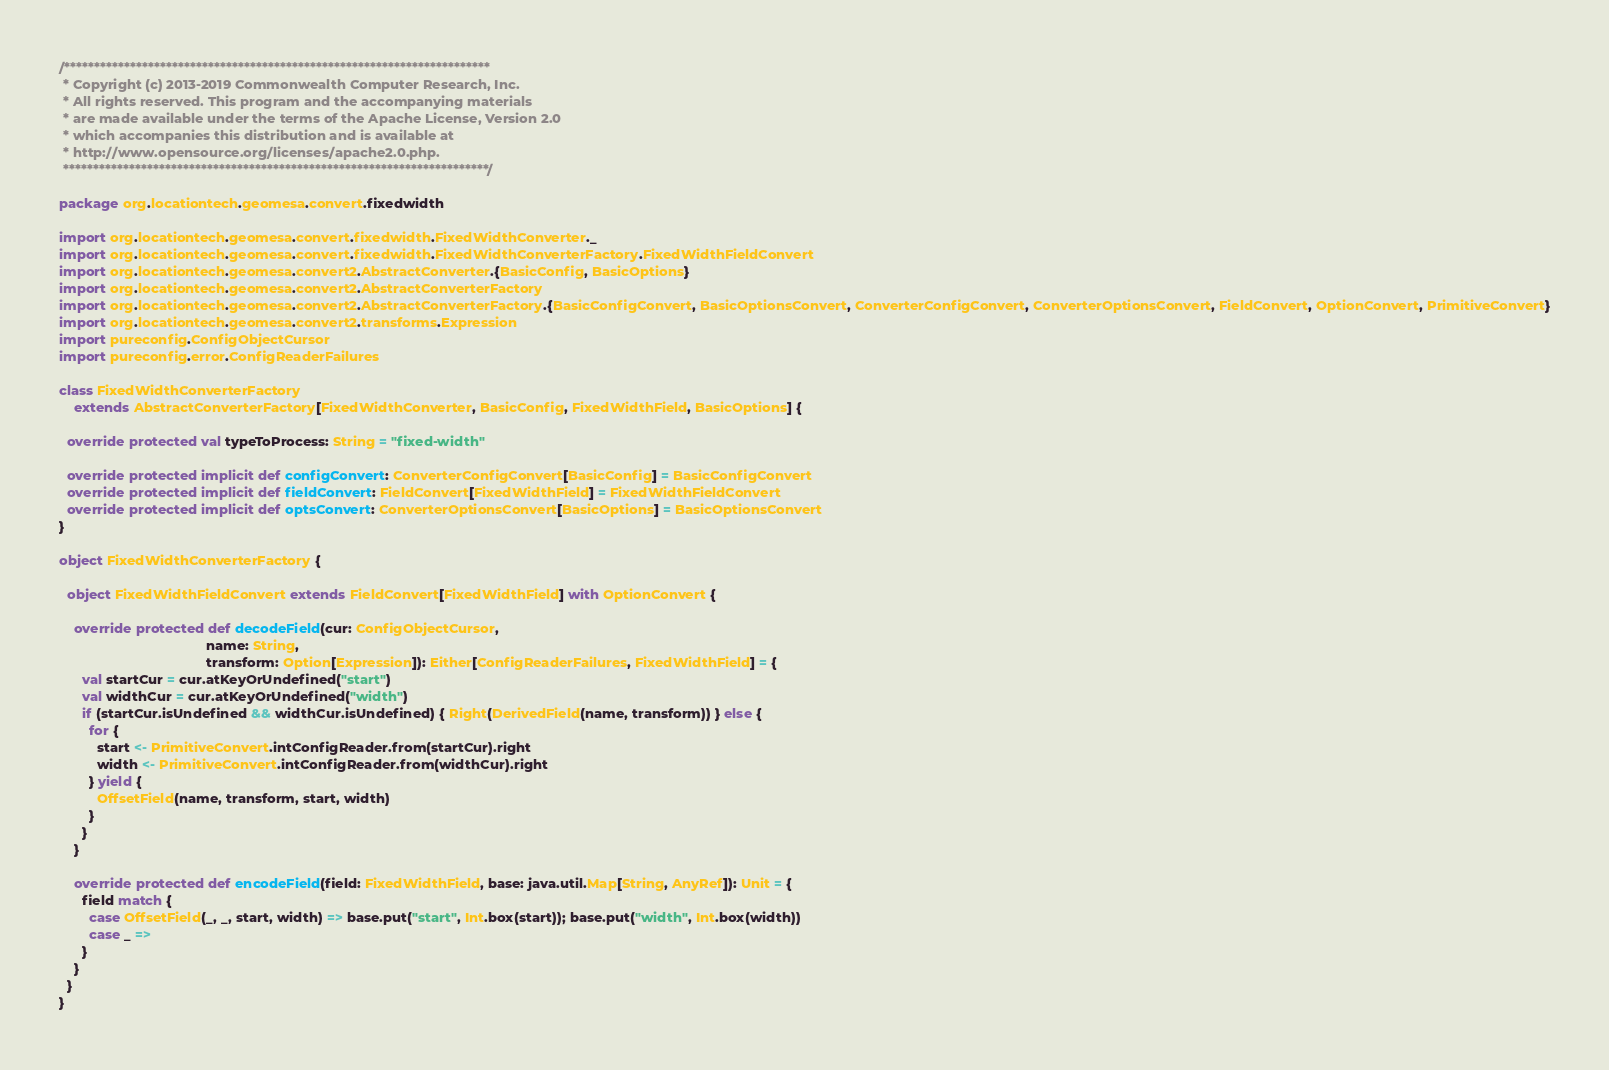Convert code to text. <code><loc_0><loc_0><loc_500><loc_500><_Scala_>/***********************************************************************
 * Copyright (c) 2013-2019 Commonwealth Computer Research, Inc.
 * All rights reserved. This program and the accompanying materials
 * are made available under the terms of the Apache License, Version 2.0
 * which accompanies this distribution and is available at
 * http://www.opensource.org/licenses/apache2.0.php.
 ***********************************************************************/

package org.locationtech.geomesa.convert.fixedwidth

import org.locationtech.geomesa.convert.fixedwidth.FixedWidthConverter._
import org.locationtech.geomesa.convert.fixedwidth.FixedWidthConverterFactory.FixedWidthFieldConvert
import org.locationtech.geomesa.convert2.AbstractConverter.{BasicConfig, BasicOptions}
import org.locationtech.geomesa.convert2.AbstractConverterFactory
import org.locationtech.geomesa.convert2.AbstractConverterFactory.{BasicConfigConvert, BasicOptionsConvert, ConverterConfigConvert, ConverterOptionsConvert, FieldConvert, OptionConvert, PrimitiveConvert}
import org.locationtech.geomesa.convert2.transforms.Expression
import pureconfig.ConfigObjectCursor
import pureconfig.error.ConfigReaderFailures

class FixedWidthConverterFactory
    extends AbstractConverterFactory[FixedWidthConverter, BasicConfig, FixedWidthField, BasicOptions] {

  override protected val typeToProcess: String = "fixed-width"

  override protected implicit def configConvert: ConverterConfigConvert[BasicConfig] = BasicConfigConvert
  override protected implicit def fieldConvert: FieldConvert[FixedWidthField] = FixedWidthFieldConvert
  override protected implicit def optsConvert: ConverterOptionsConvert[BasicOptions] = BasicOptionsConvert
}

object FixedWidthConverterFactory {

  object FixedWidthFieldConvert extends FieldConvert[FixedWidthField] with OptionConvert {

    override protected def decodeField(cur: ConfigObjectCursor,
                                       name: String,
                                       transform: Option[Expression]): Either[ConfigReaderFailures, FixedWidthField] = {
      val startCur = cur.atKeyOrUndefined("start")
      val widthCur = cur.atKeyOrUndefined("width")
      if (startCur.isUndefined && widthCur.isUndefined) { Right(DerivedField(name, transform)) } else {
        for {
          start <- PrimitiveConvert.intConfigReader.from(startCur).right
          width <- PrimitiveConvert.intConfigReader.from(widthCur).right
        } yield {
          OffsetField(name, transform, start, width)
        }
      }
    }

    override protected def encodeField(field: FixedWidthField, base: java.util.Map[String, AnyRef]): Unit = {
      field match {
        case OffsetField(_, _, start, width) => base.put("start", Int.box(start)); base.put("width", Int.box(width))
        case _ =>
      }
    }
  }
}
</code> 